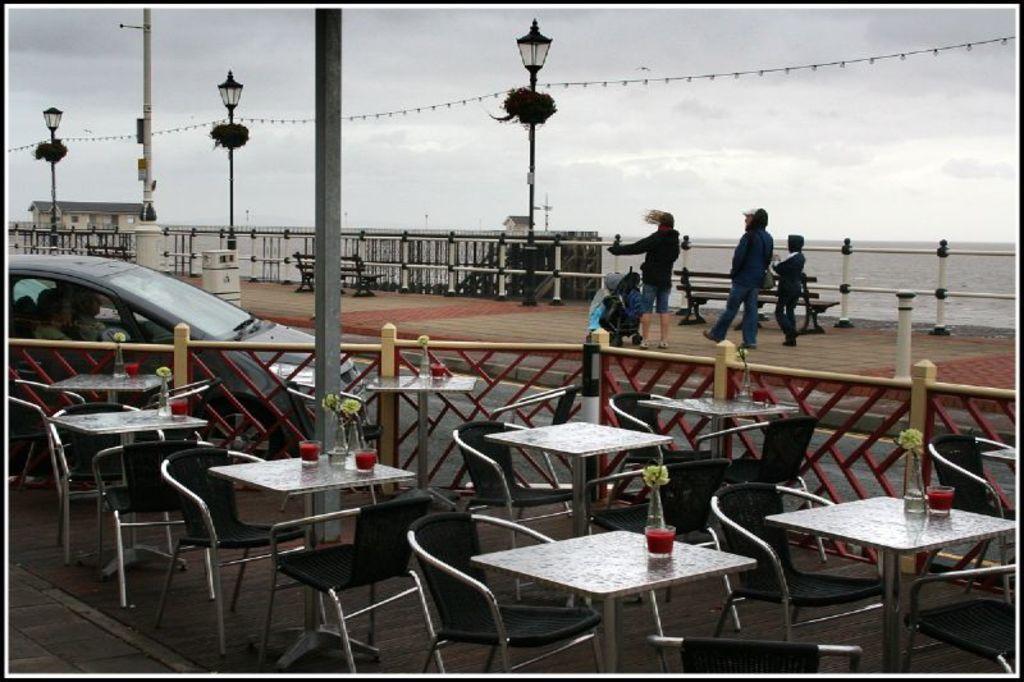Can you describe this image briefly? In this image we can see some people on the ground, some benches, baby carrier and some chairs placed on the ground, we can also see some plants, glasses placed on the tables. In the center of the image we can see a fence and some poles. On the left side of the image we can see two people in a vehicle, a building with windows and roof. In the background, we can see some light poles, water and the sky. 